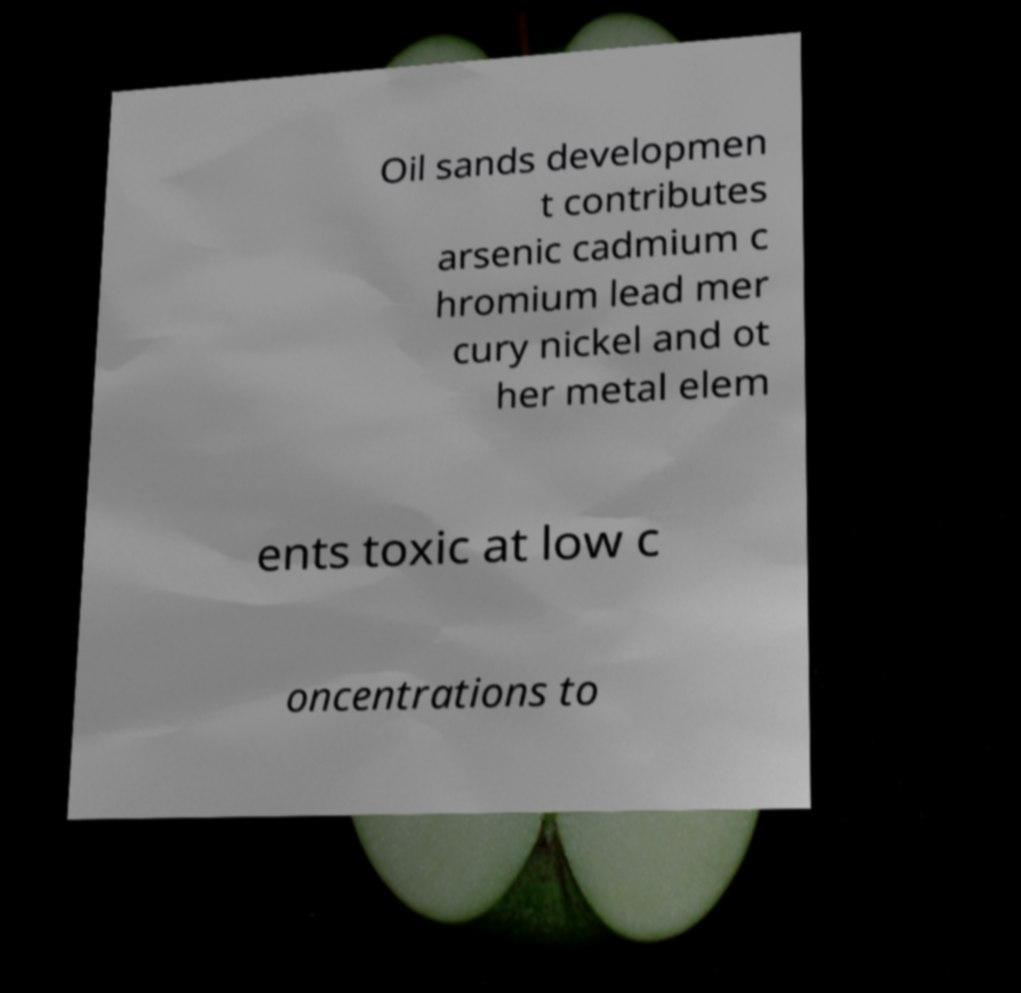Could you extract and type out the text from this image? Oil sands developmen t contributes arsenic cadmium c hromium lead mer cury nickel and ot her metal elem ents toxic at low c oncentrations to 